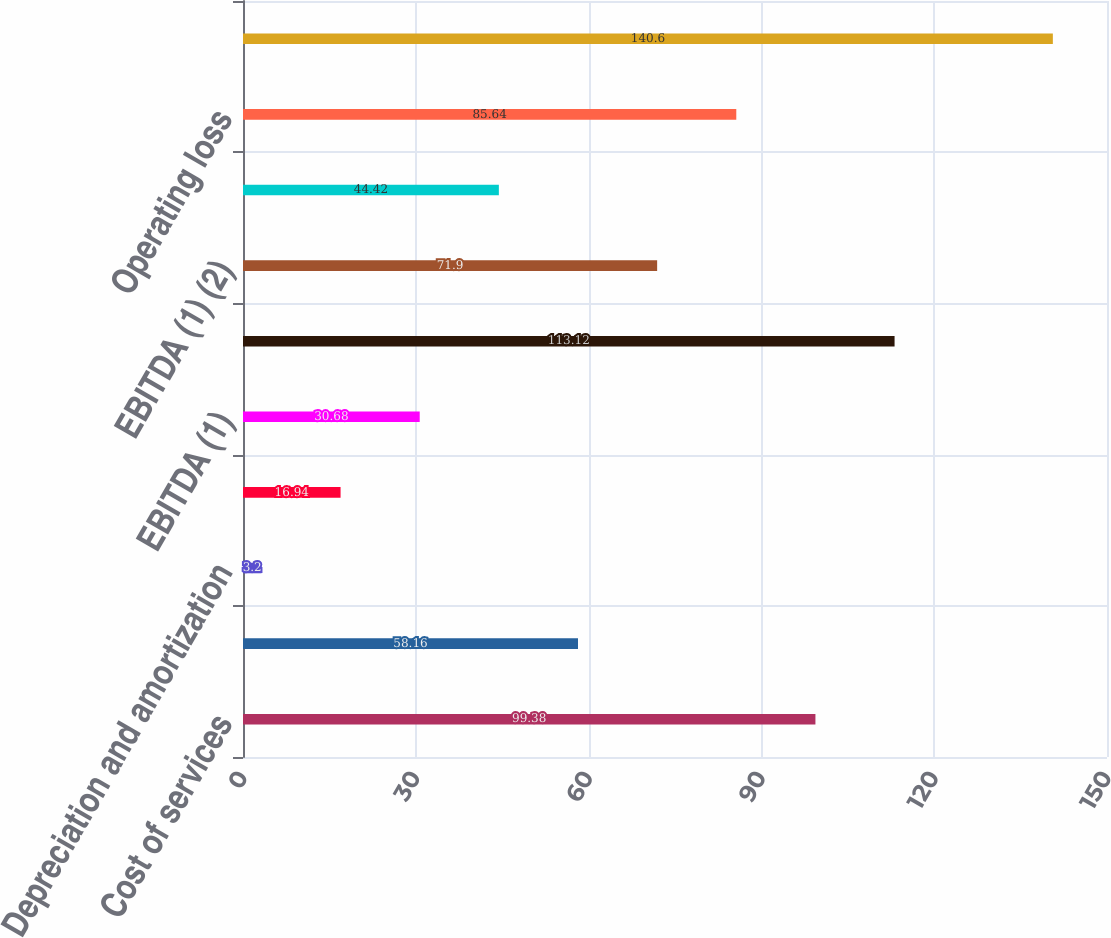<chart> <loc_0><loc_0><loc_500><loc_500><bar_chart><fcel>Cost of services<fcel>Operating administrative and<fcel>Depreciation and amortization<fcel>Operating income<fcel>EBITDA (1)<fcel>Revenue<fcel>EBITDA (1) (2)<fcel>Gain on disposition of real<fcel>Operating loss<fcel>EBITDA (1) (3)<nl><fcel>99.38<fcel>58.16<fcel>3.2<fcel>16.94<fcel>30.68<fcel>113.12<fcel>71.9<fcel>44.42<fcel>85.64<fcel>140.6<nl></chart> 